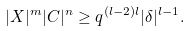<formula> <loc_0><loc_0><loc_500><loc_500>| X | ^ { m } | C | ^ { n } \geq q ^ { ( l - 2 ) l } | \delta | ^ { l - 1 } .</formula> 